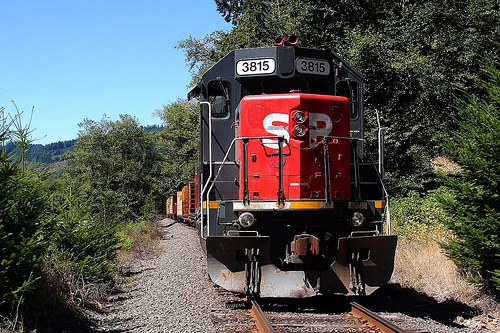Describe the objects in this image and their specific colors. I can see a train in lightblue, black, gray, red, and maroon tones in this image. 